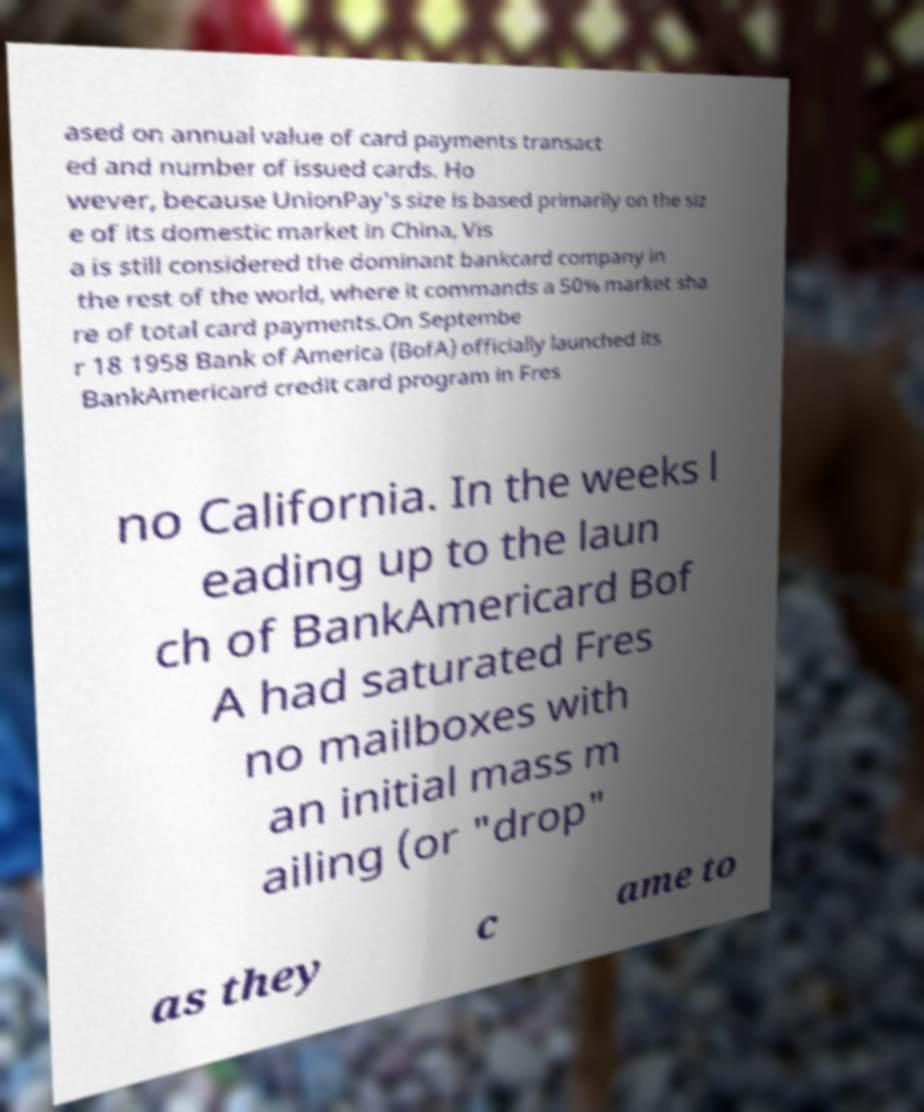Please identify and transcribe the text found in this image. ased on annual value of card payments transact ed and number of issued cards. Ho wever, because UnionPay's size is based primarily on the siz e of its domestic market in China, Vis a is still considered the dominant bankcard company in the rest of the world, where it commands a 50% market sha re of total card payments.On Septembe r 18 1958 Bank of America (BofA) officially launched its BankAmericard credit card program in Fres no California. In the weeks l eading up to the laun ch of BankAmericard Bof A had saturated Fres no mailboxes with an initial mass m ailing (or "drop" as they c ame to 